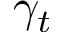<formula> <loc_0><loc_0><loc_500><loc_500>\gamma _ { t }</formula> 